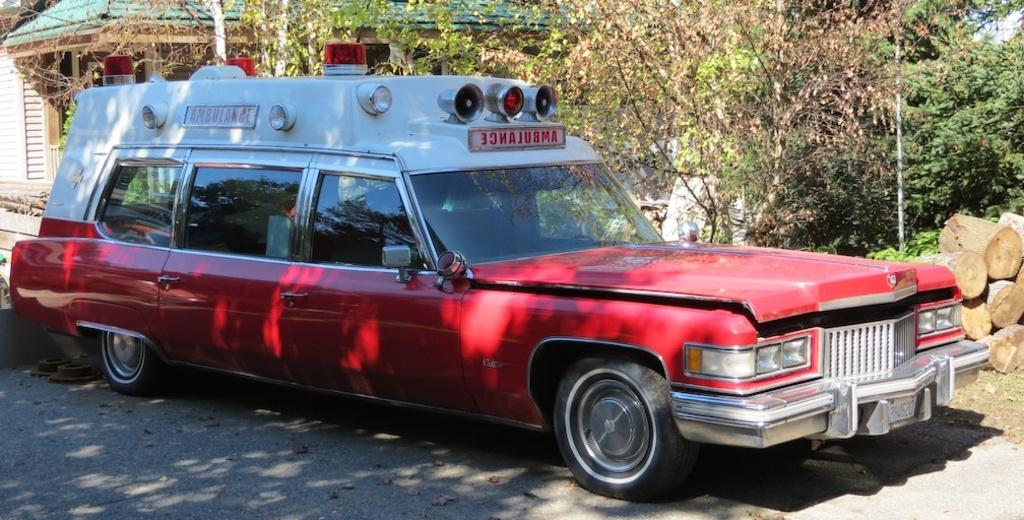What is the main subject of the image? There is a car on the road in the image. What can be seen in the background of the image? There is a house, trees, wooden logs, and a pole in the background of the image. How many people are saying good-bye to each other in the image? There is no indication of people saying good-bye in the image; it primarily features a car on the road and various background elements. 